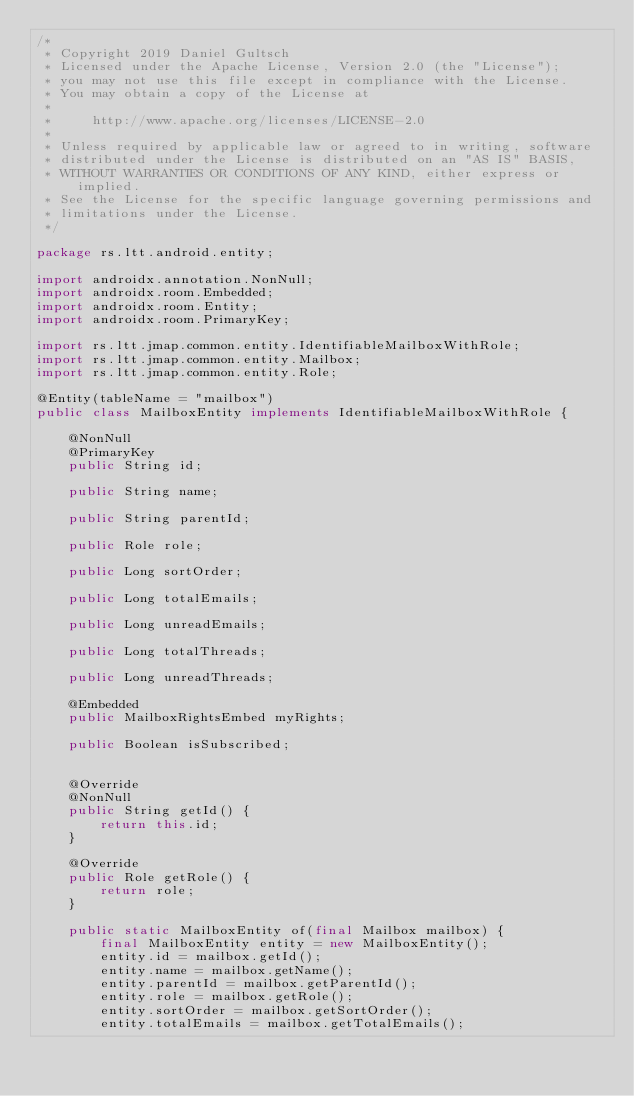<code> <loc_0><loc_0><loc_500><loc_500><_Java_>/*
 * Copyright 2019 Daniel Gultsch
 * Licensed under the Apache License, Version 2.0 (the "License");
 * you may not use this file except in compliance with the License.
 * You may obtain a copy of the License at
 *
 *     http://www.apache.org/licenses/LICENSE-2.0
 *
 * Unless required by applicable law or agreed to in writing, software
 * distributed under the License is distributed on an "AS IS" BASIS,
 * WITHOUT WARRANTIES OR CONDITIONS OF ANY KIND, either express or implied.
 * See the License for the specific language governing permissions and
 * limitations under the License.
 */

package rs.ltt.android.entity;

import androidx.annotation.NonNull;
import androidx.room.Embedded;
import androidx.room.Entity;
import androidx.room.PrimaryKey;

import rs.ltt.jmap.common.entity.IdentifiableMailboxWithRole;
import rs.ltt.jmap.common.entity.Mailbox;
import rs.ltt.jmap.common.entity.Role;

@Entity(tableName = "mailbox")
public class MailboxEntity implements IdentifiableMailboxWithRole {

    @NonNull
    @PrimaryKey
    public String id;

    public String name;

    public String parentId;

    public Role role;

    public Long sortOrder;

    public Long totalEmails;

    public Long unreadEmails;

    public Long totalThreads;

    public Long unreadThreads;

    @Embedded
    public MailboxRightsEmbed myRights;

    public Boolean isSubscribed;


    @Override
    @NonNull
    public String getId() {
        return this.id;
    }

    @Override
    public Role getRole() {
        return role;
    }

    public static MailboxEntity of(final Mailbox mailbox) {
        final MailboxEntity entity = new MailboxEntity();
        entity.id = mailbox.getId();
        entity.name = mailbox.getName();
        entity.parentId = mailbox.getParentId();
        entity.role = mailbox.getRole();
        entity.sortOrder = mailbox.getSortOrder();
        entity.totalEmails = mailbox.getTotalEmails();</code> 